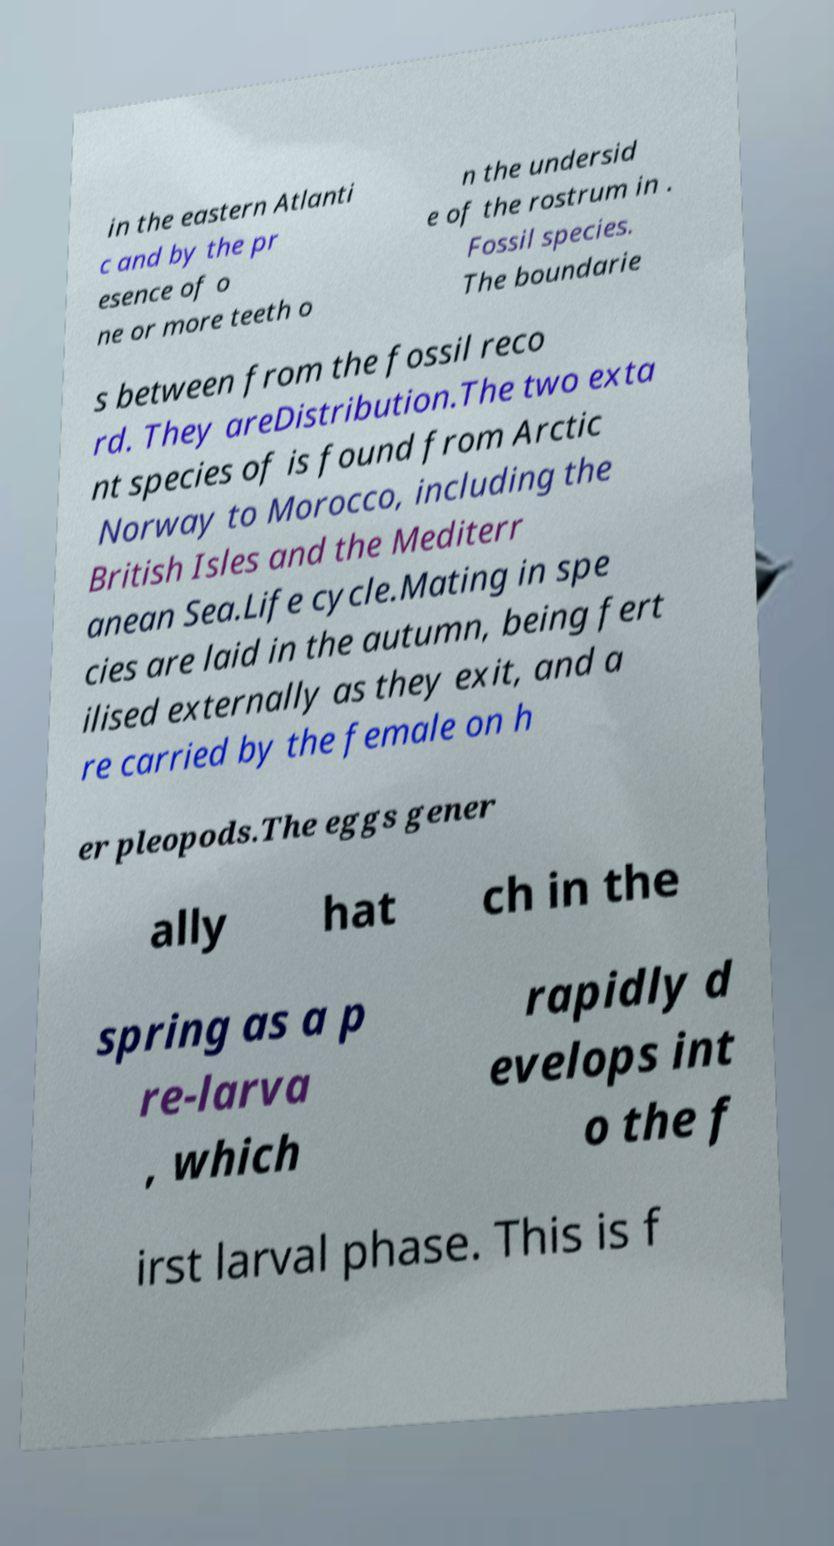Could you assist in decoding the text presented in this image and type it out clearly? in the eastern Atlanti c and by the pr esence of o ne or more teeth o n the undersid e of the rostrum in . Fossil species. The boundarie s between from the fossil reco rd. They areDistribution.The two exta nt species of is found from Arctic Norway to Morocco, including the British Isles and the Mediterr anean Sea.Life cycle.Mating in spe cies are laid in the autumn, being fert ilised externally as they exit, and a re carried by the female on h er pleopods.The eggs gener ally hat ch in the spring as a p re-larva , which rapidly d evelops int o the f irst larval phase. This is f 